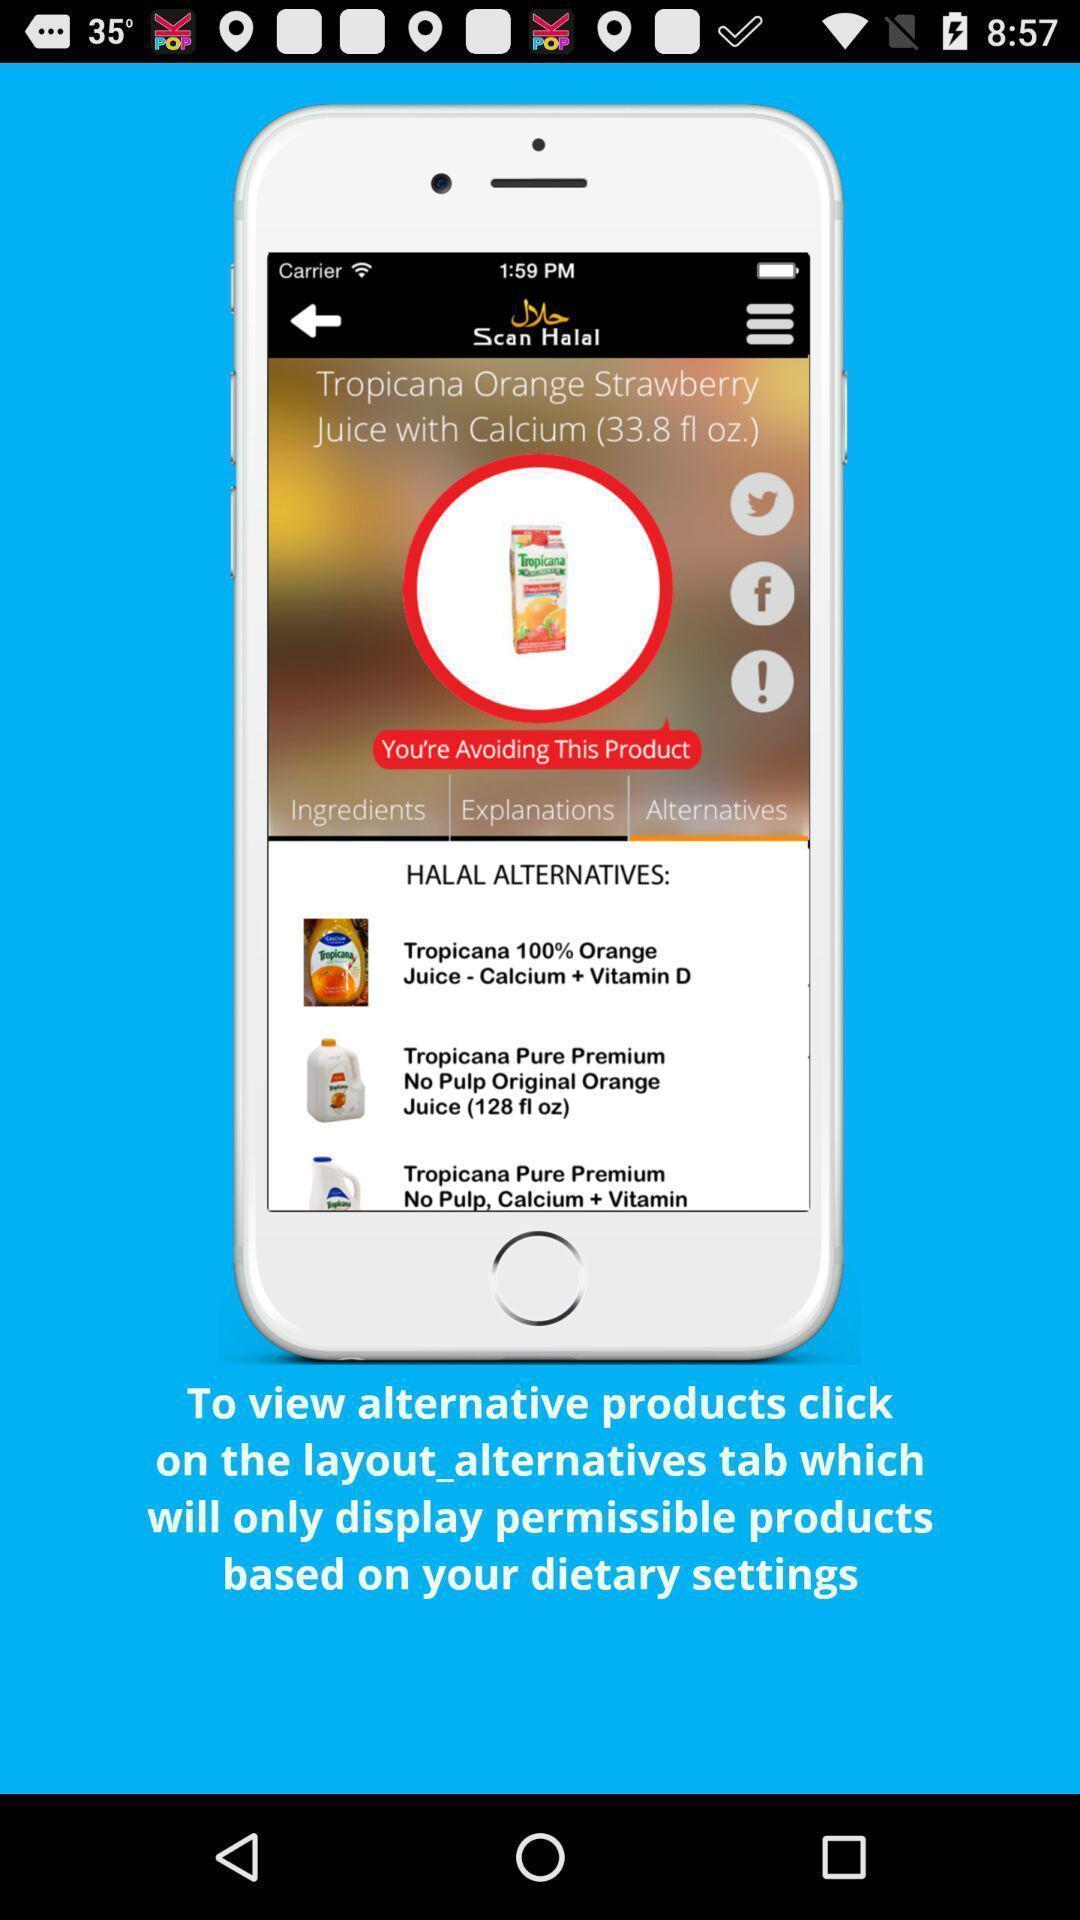Tell me what you see in this picture. Page showing tips to use an app. 